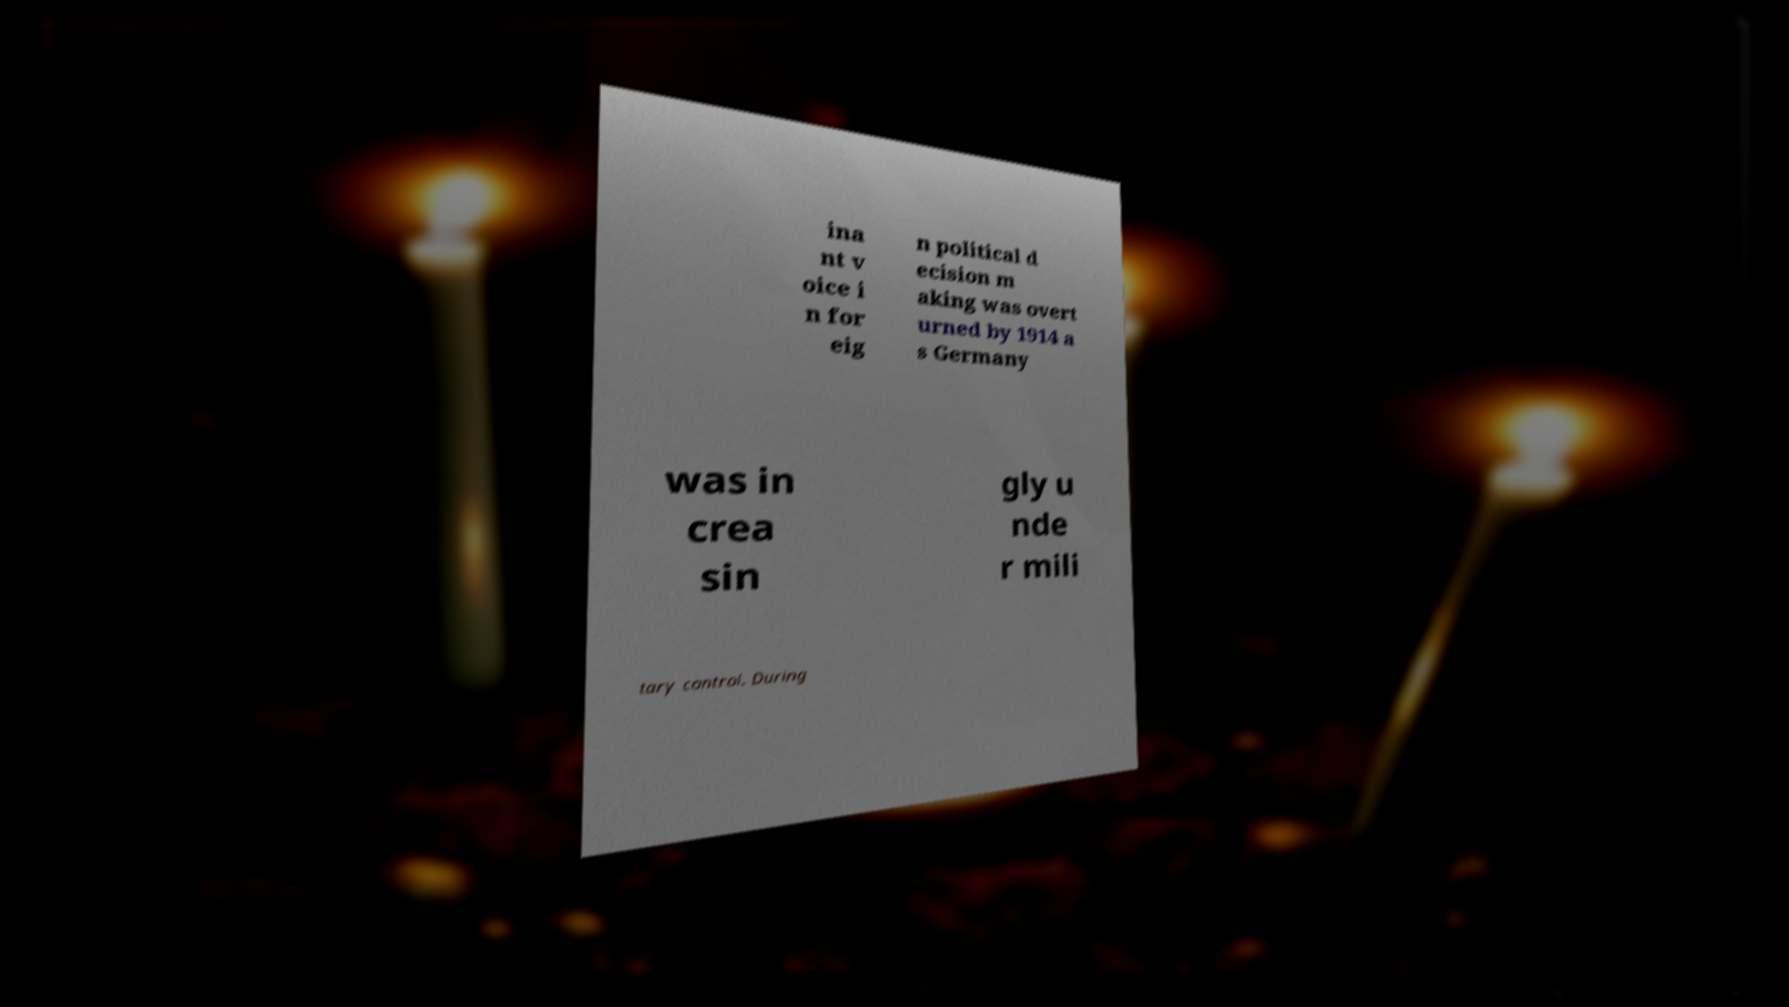For documentation purposes, I need the text within this image transcribed. Could you provide that? ina nt v oice i n for eig n political d ecision m aking was overt urned by 1914 a s Germany was in crea sin gly u nde r mili tary control. During 